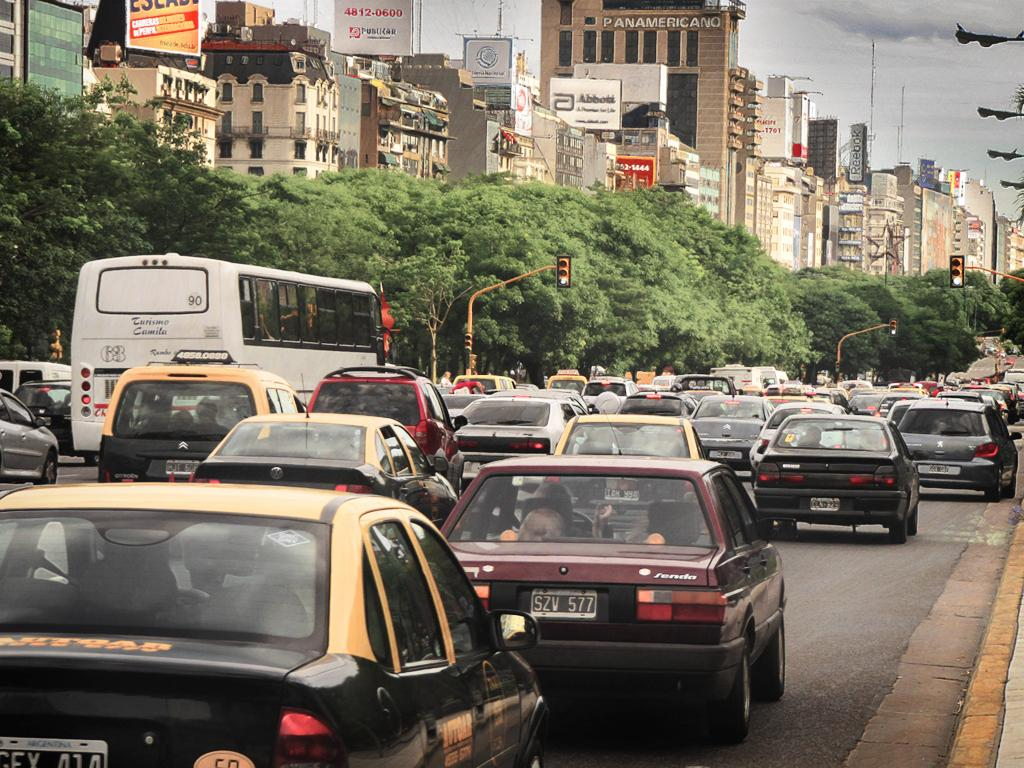<image>
Write a terse but informative summary of the picture. The Panamericano Building stands tall over a busy thoroughfare. 